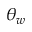<formula> <loc_0><loc_0><loc_500><loc_500>\theta _ { w }</formula> 